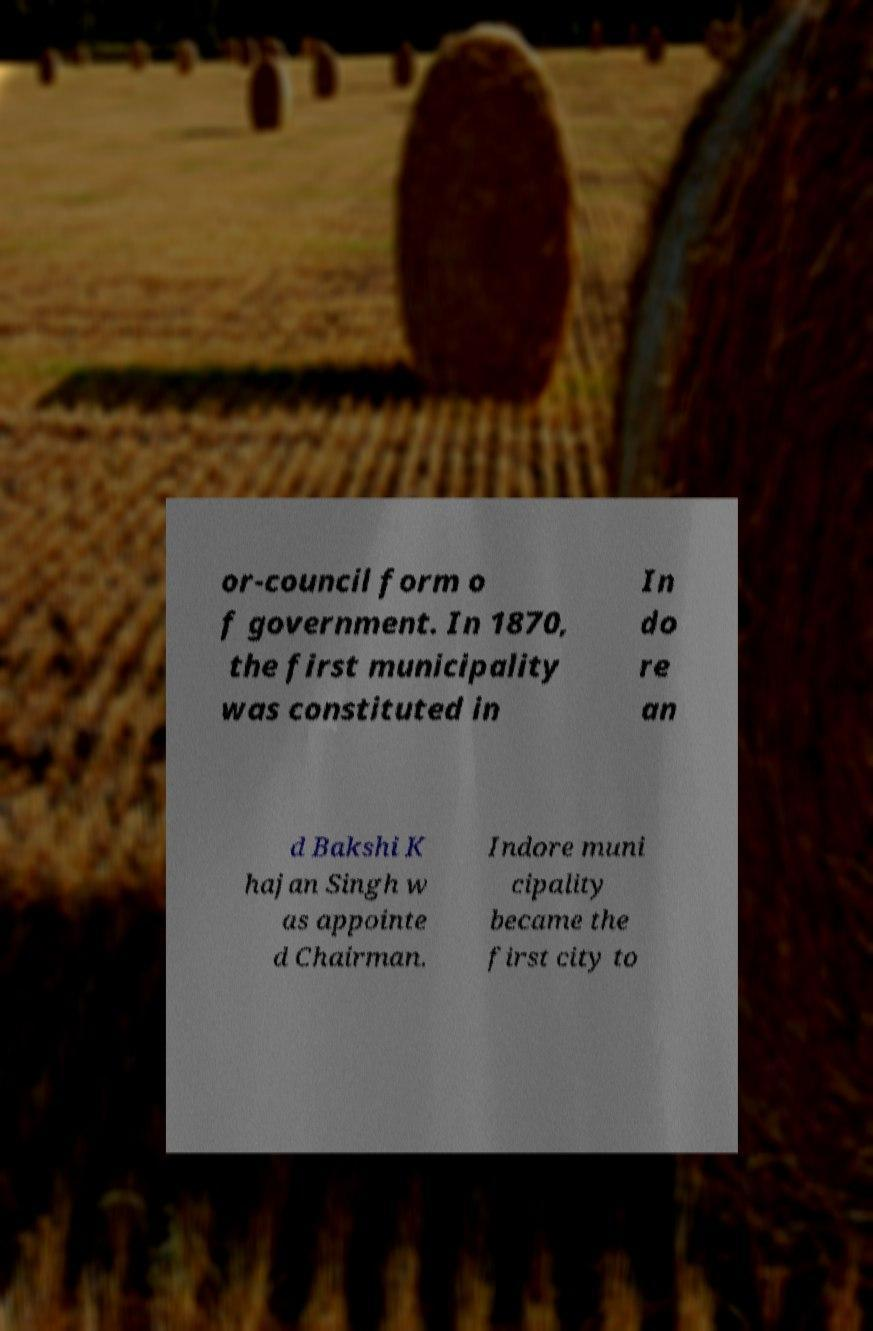For documentation purposes, I need the text within this image transcribed. Could you provide that? or-council form o f government. In 1870, the first municipality was constituted in In do re an d Bakshi K hajan Singh w as appointe d Chairman. Indore muni cipality became the first city to 